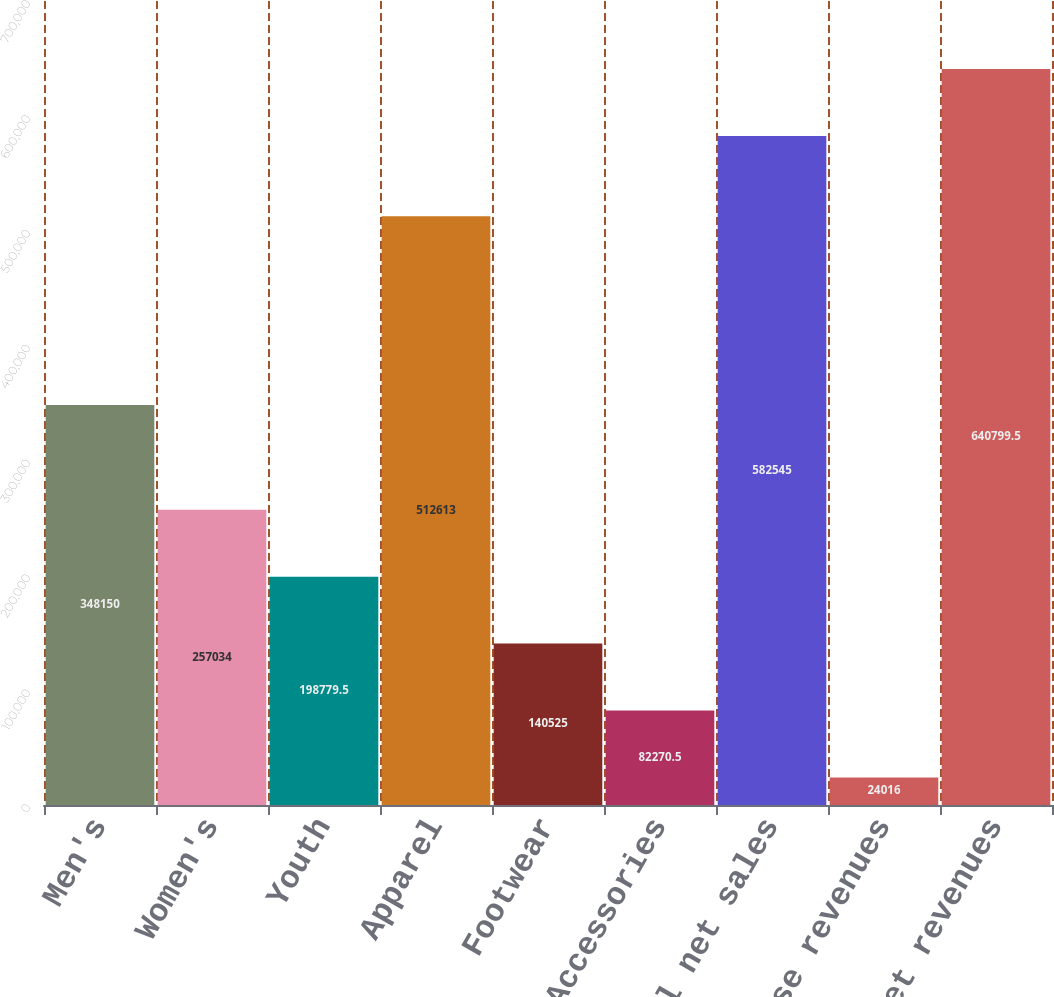Convert chart to OTSL. <chart><loc_0><loc_0><loc_500><loc_500><bar_chart><fcel>Men's<fcel>Women's<fcel>Youth<fcel>Apparel<fcel>Footwear<fcel>Accessories<fcel>Total net sales<fcel>License revenues<fcel>Total net revenues<nl><fcel>348150<fcel>257034<fcel>198780<fcel>512613<fcel>140525<fcel>82270.5<fcel>582545<fcel>24016<fcel>640800<nl></chart> 